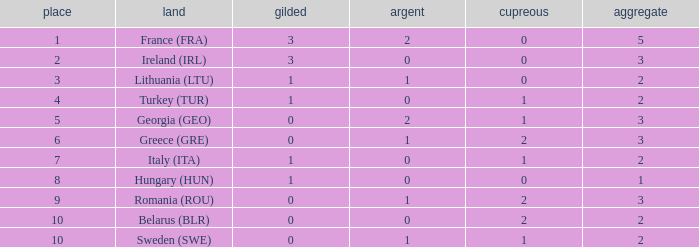Parse the table in full. {'header': ['place', 'land', 'gilded', 'argent', 'cupreous', 'aggregate'], 'rows': [['1', 'France (FRA)', '3', '2', '0', '5'], ['2', 'Ireland (IRL)', '3', '0', '0', '3'], ['3', 'Lithuania (LTU)', '1', '1', '0', '2'], ['4', 'Turkey (TUR)', '1', '0', '1', '2'], ['5', 'Georgia (GEO)', '0', '2', '1', '3'], ['6', 'Greece (GRE)', '0', '1', '2', '3'], ['7', 'Italy (ITA)', '1', '0', '1', '2'], ['8', 'Hungary (HUN)', '1', '0', '0', '1'], ['9', 'Romania (ROU)', '0', '1', '2', '3'], ['10', 'Belarus (BLR)', '0', '0', '2', '2'], ['10', 'Sweden (SWE)', '0', '1', '1', '2']]} What's the total when the gold is less than 0 and silver is less than 1? None. 